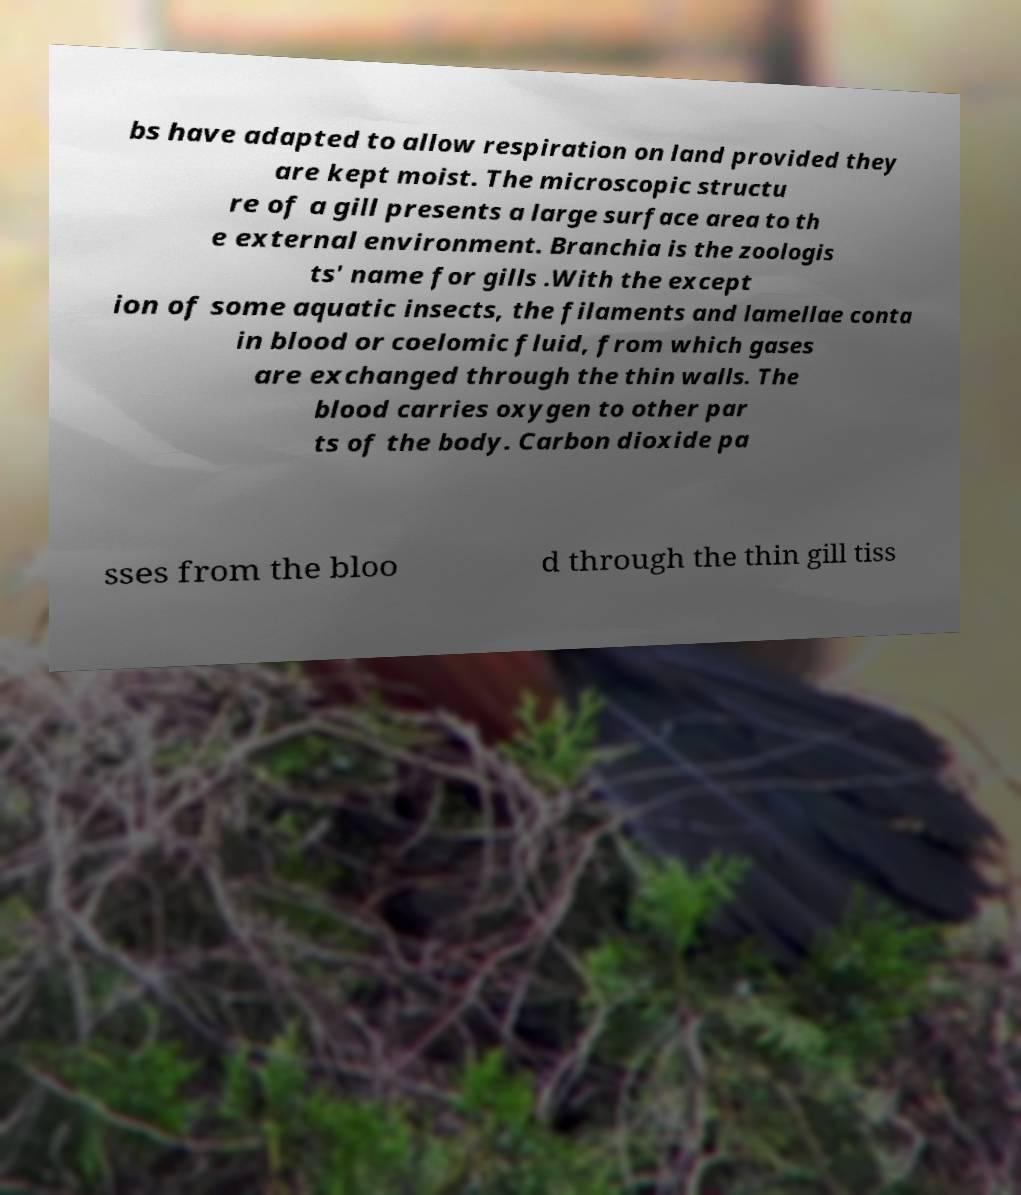What messages or text are displayed in this image? I need them in a readable, typed format. bs have adapted to allow respiration on land provided they are kept moist. The microscopic structu re of a gill presents a large surface area to th e external environment. Branchia is the zoologis ts' name for gills .With the except ion of some aquatic insects, the filaments and lamellae conta in blood or coelomic fluid, from which gases are exchanged through the thin walls. The blood carries oxygen to other par ts of the body. Carbon dioxide pa sses from the bloo d through the thin gill tiss 